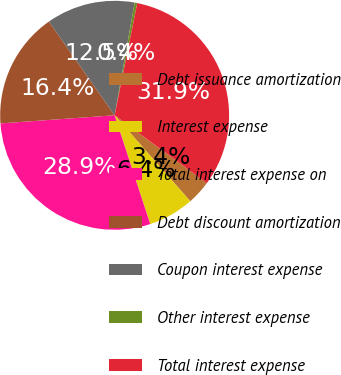Convert chart. <chart><loc_0><loc_0><loc_500><loc_500><pie_chart><fcel>Debt issuance amortization<fcel>Interest expense<fcel>Total interest expense on<fcel>Debt discount amortization<fcel>Coupon interest expense<fcel>Other interest expense<fcel>Total interest expense<nl><fcel>3.41%<fcel>6.45%<fcel>28.9%<fcel>16.4%<fcel>12.53%<fcel>0.37%<fcel>31.94%<nl></chart> 